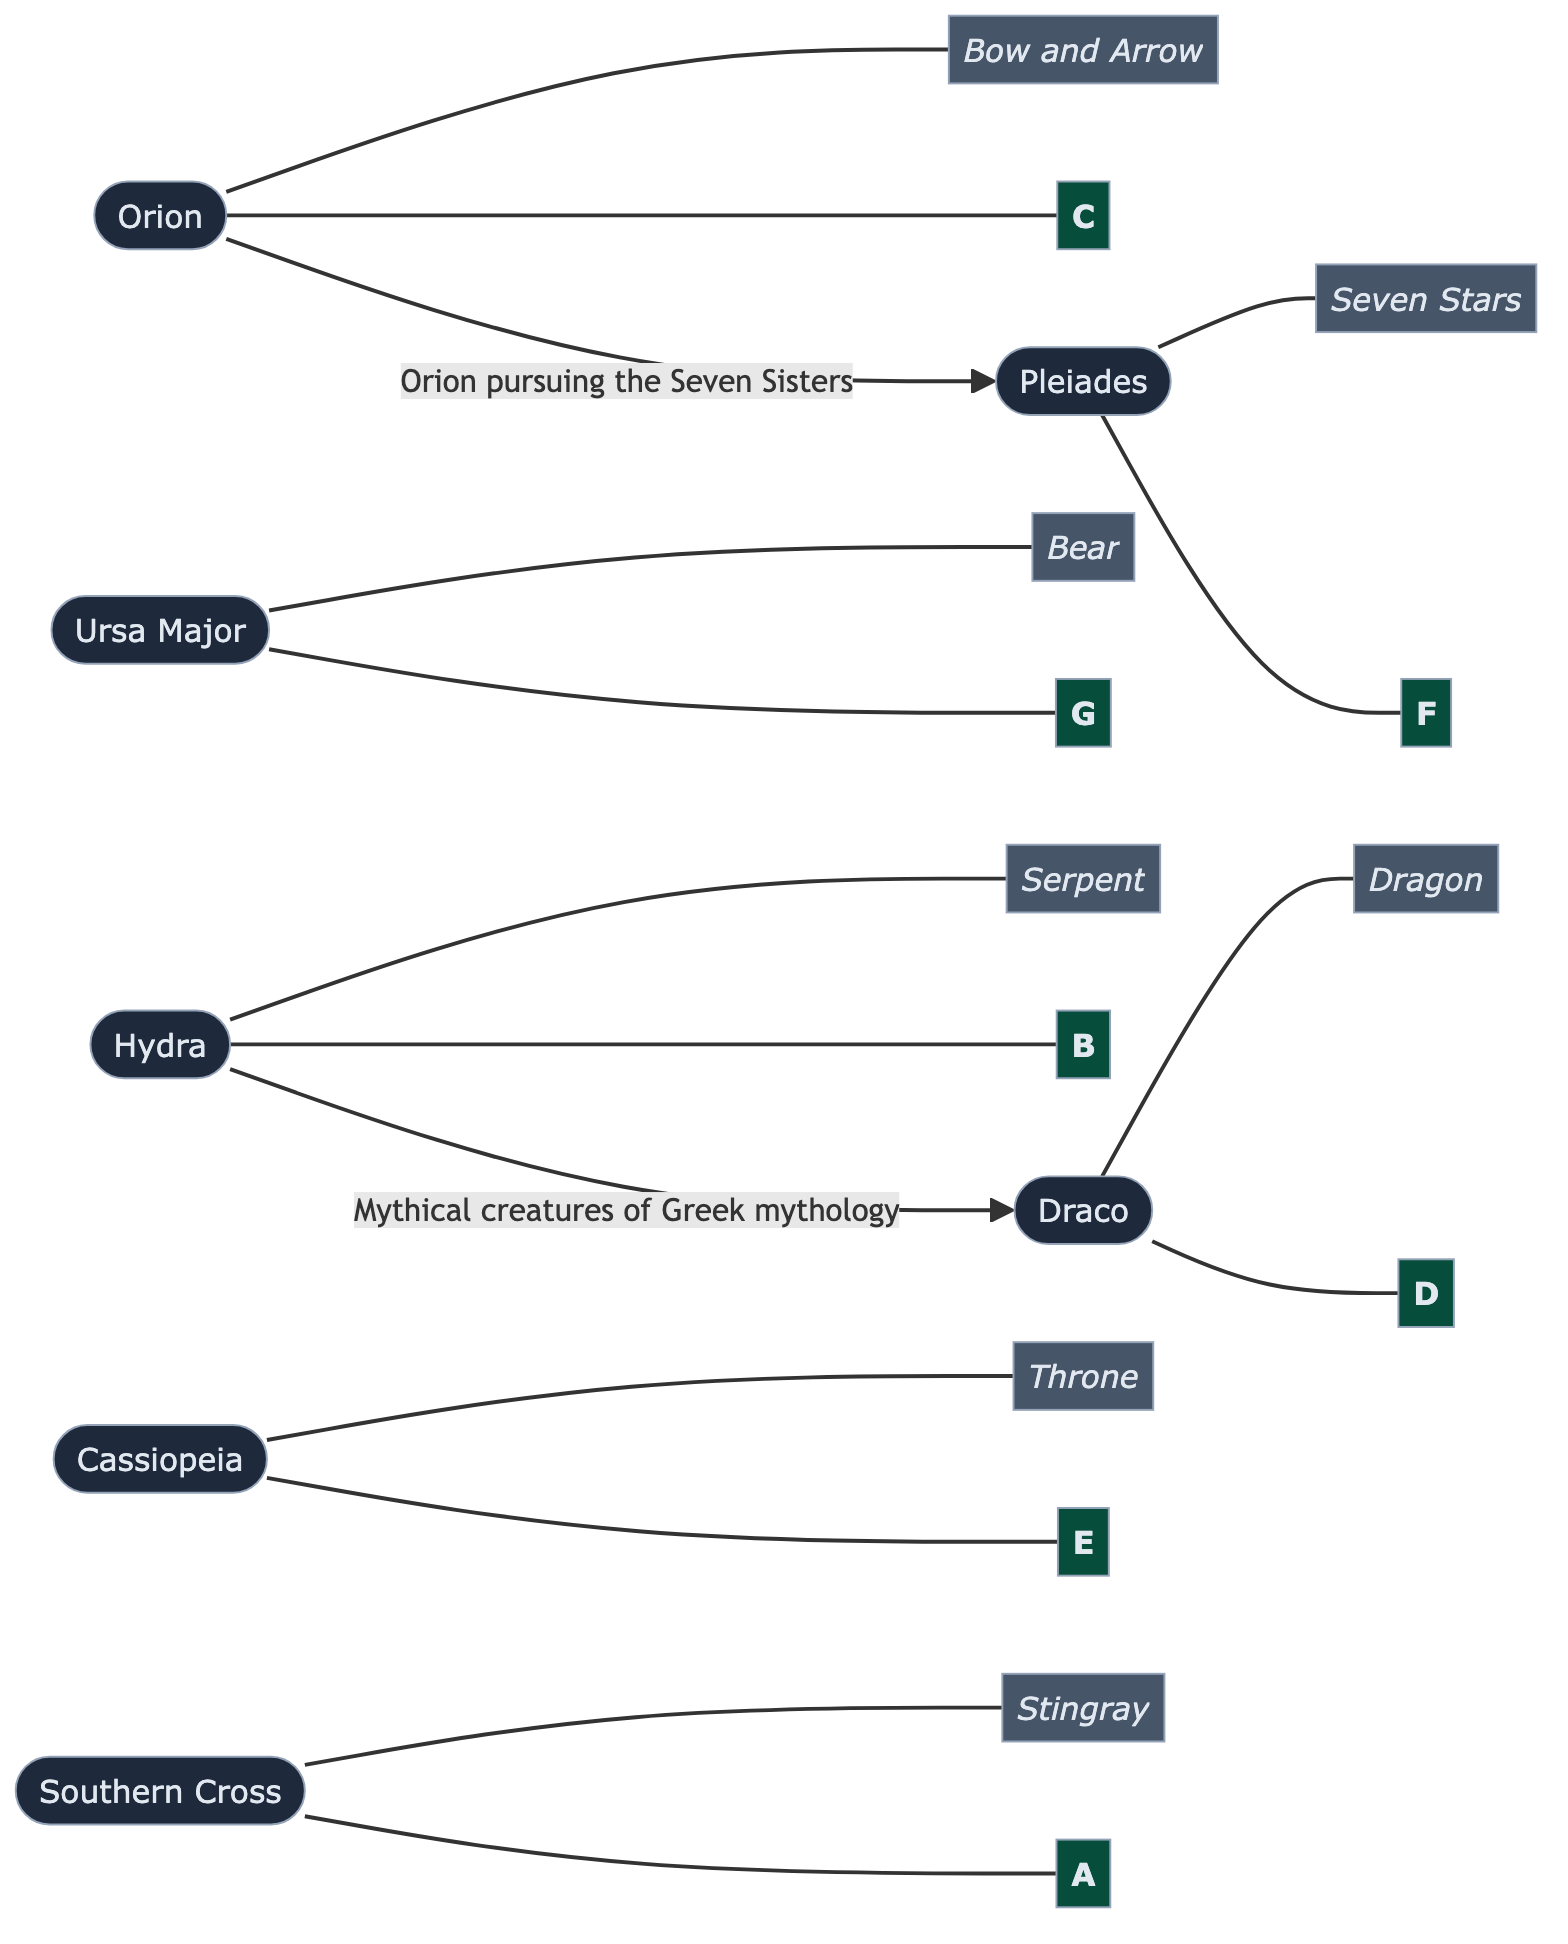What are the two constellations connected by a relationship in the diagram? The diagram shows that Orion is connected to Pleiades, and Hydra is connected to Draco. These connections indicate relationships between the constellations.
Answer: Orion, Pleiades; Hydra, Draco What symbol is associated with Ursa Major? The symbol associated with Ursa Major is "Bear" as indicated in the diagram. Each constellation is connected to its respective symbol.
Answer: Bear How many constellations are listed in the diagram? The diagram shows a total of seven constellations (Orion, Ursa Major, Cassiopeia, Draco, Southern Cross, Pleiades, Hydra). Therefore, we count them from the nodes representing each constellation.
Answer: 7 Which constellation is connected to the note "D"? Draco is associated with the musical note "D" according to the connections made in the diagram. Each constellation has a corresponding musical note.
Answer: Draco What is the relationship described for Orion and Pleiades? The relationship described in the diagram indicates that "Orion is pursuing the Seven Sisters," connecting the mythological story behind these constellations.
Answer: Orion pursuing the Seven Sisters Which note is associated with Southern Cross? The musical note associated with Southern Cross is "A." This relationship is clearly defined within the nodes in the diagram.
Answer: A Which two constellations are related to Greek mythology? Hydra is linked to Draco in the context of "Mythical creatures of Greek mythology," establishing their relationship through the cultural background.
Answer: Hydra, Draco What is the symbol representing Pleiades? The symbol associated with Pleiades is "Seven Stars," as specified in the diagram. Each constellation corresponds with its own cultural symbol.
Answer: Seven Stars 